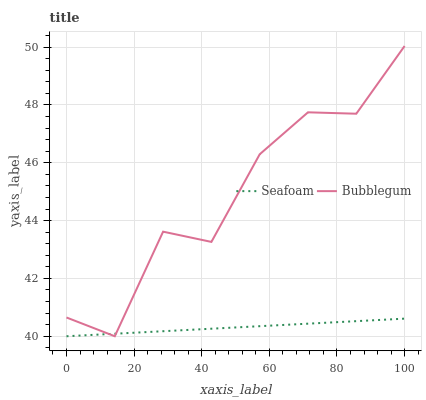Does Seafoam have the minimum area under the curve?
Answer yes or no. Yes. Does Bubblegum have the maximum area under the curve?
Answer yes or no. Yes. Does Bubblegum have the minimum area under the curve?
Answer yes or no. No. Is Seafoam the smoothest?
Answer yes or no. Yes. Is Bubblegum the roughest?
Answer yes or no. Yes. Is Bubblegum the smoothest?
Answer yes or no. No. Does Seafoam have the lowest value?
Answer yes or no. Yes. Does Bubblegum have the highest value?
Answer yes or no. Yes. Does Bubblegum intersect Seafoam?
Answer yes or no. Yes. Is Bubblegum less than Seafoam?
Answer yes or no. No. Is Bubblegum greater than Seafoam?
Answer yes or no. No. 